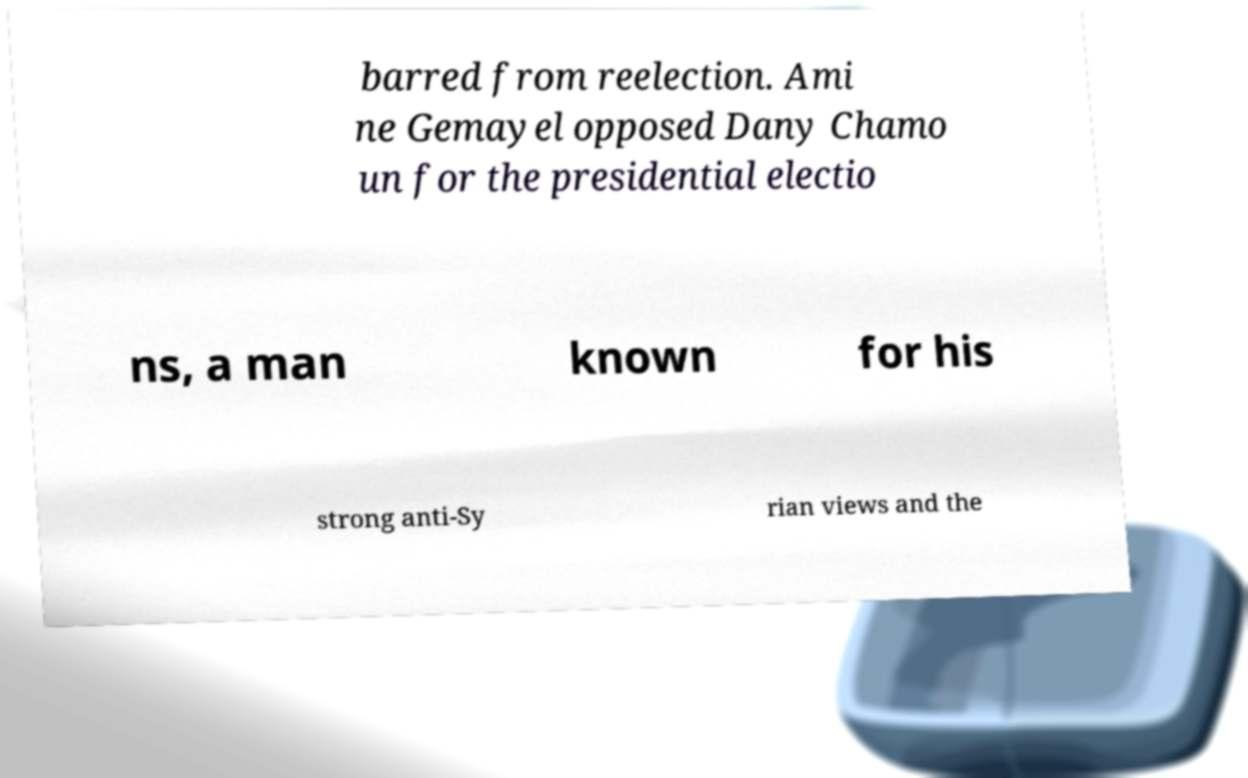Please read and relay the text visible in this image. What does it say? barred from reelection. Ami ne Gemayel opposed Dany Chamo un for the presidential electio ns, a man known for his strong anti-Sy rian views and the 